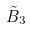Convert formula to latex. <formula><loc_0><loc_0><loc_500><loc_500>\tilde { B } _ { 3 }</formula> 